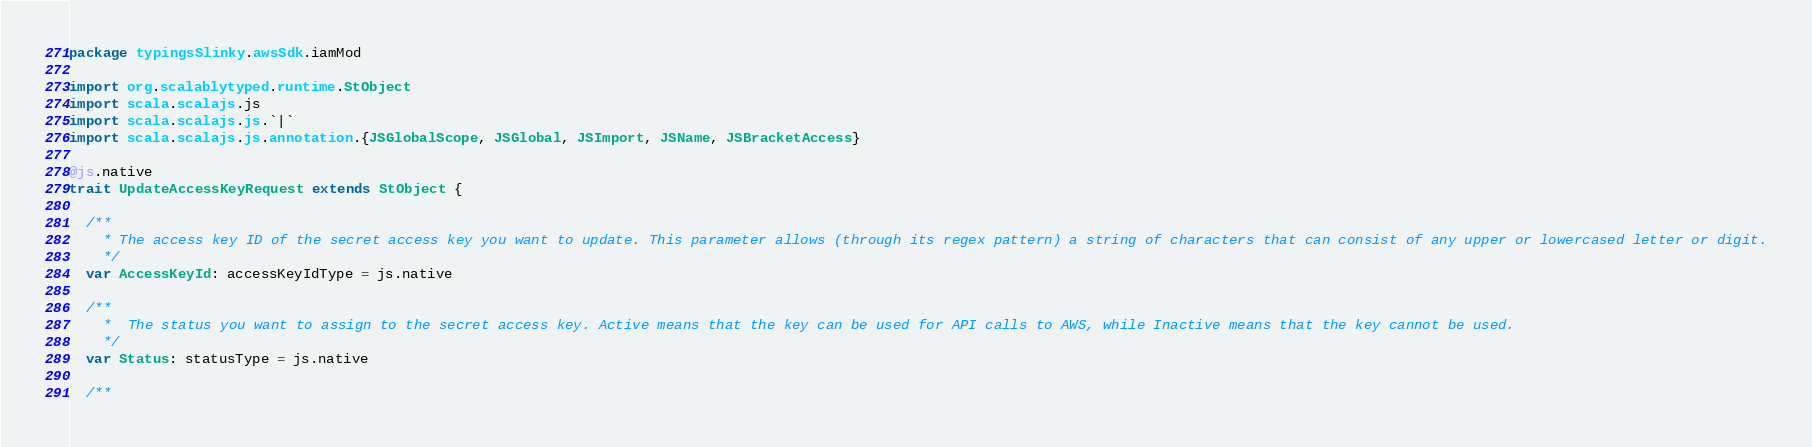Convert code to text. <code><loc_0><loc_0><loc_500><loc_500><_Scala_>package typingsSlinky.awsSdk.iamMod

import org.scalablytyped.runtime.StObject
import scala.scalajs.js
import scala.scalajs.js.`|`
import scala.scalajs.js.annotation.{JSGlobalScope, JSGlobal, JSImport, JSName, JSBracketAccess}

@js.native
trait UpdateAccessKeyRequest extends StObject {
  
  /**
    * The access key ID of the secret access key you want to update. This parameter allows (through its regex pattern) a string of characters that can consist of any upper or lowercased letter or digit.
    */
  var AccessKeyId: accessKeyIdType = js.native
  
  /**
    *  The status you want to assign to the secret access key. Active means that the key can be used for API calls to AWS, while Inactive means that the key cannot be used.
    */
  var Status: statusType = js.native
  
  /**</code> 